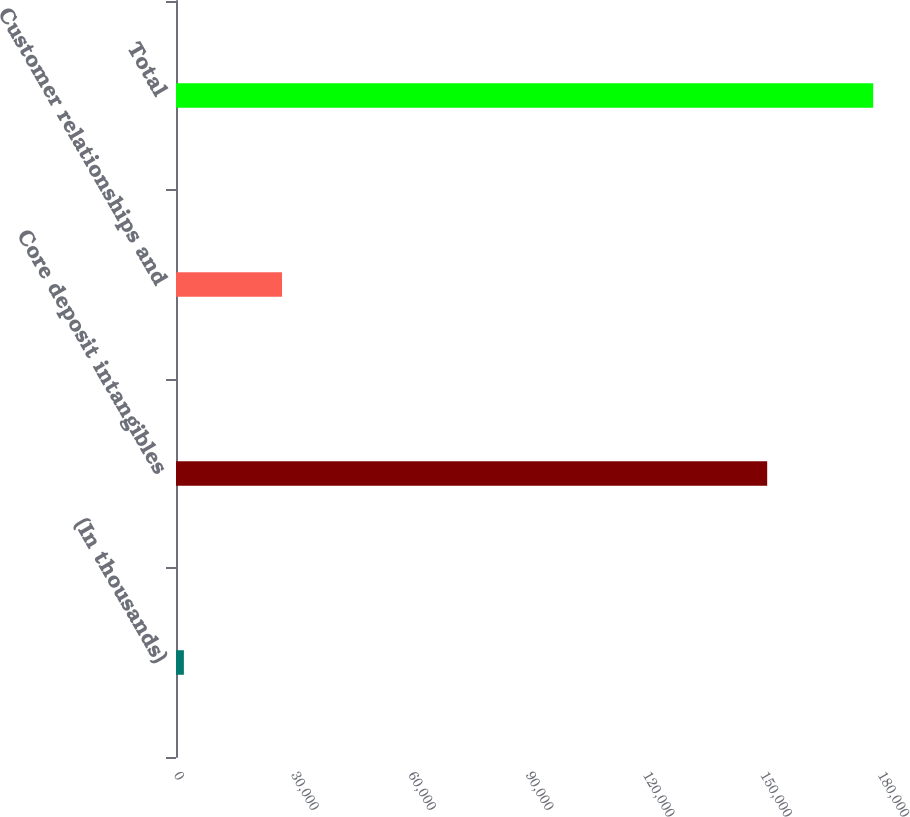Convert chart to OTSL. <chart><loc_0><loc_0><loc_500><loc_500><bar_chart><fcel>(In thousands)<fcel>Core deposit intangibles<fcel>Customer relationships and<fcel>Total<nl><fcel>2015<fcel>151157<fcel>27103<fcel>178260<nl></chart> 